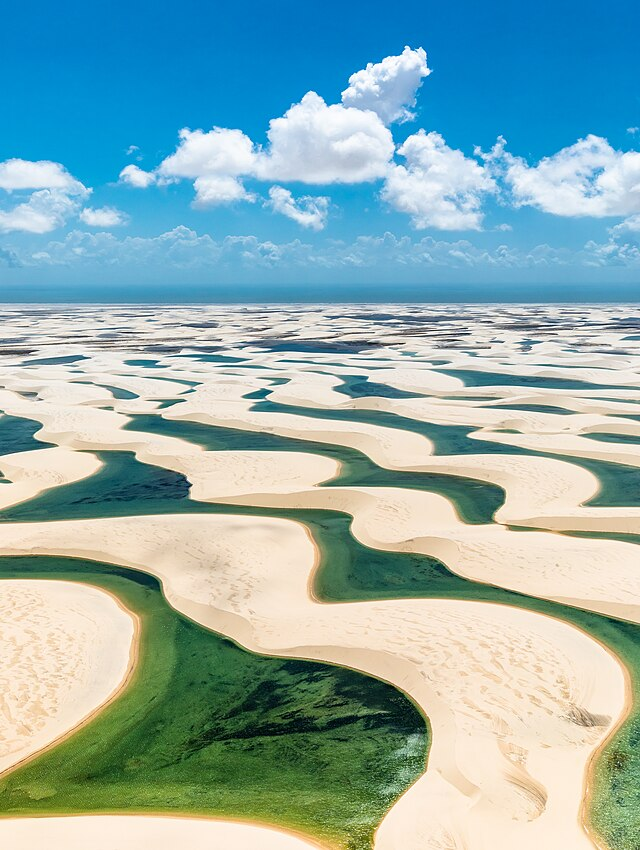What do you think is going on in this snapshot? The snapshot presents a stunning aerial view of Brazil's Lençóis Maranhenses National Park. The visual is striking, with waves of stark white sand dunes stretching across the landscape, reminiscent of an otherworldly desert. But, unlike a typical desert, the meandering patterns are occasionally punctuated by tranquil lagoons, their waters ranging from azure to emerald, a seasonal phenomenon caused by the region's rainfall. The contrast is visually arresting and speaks to the unique ecosystem here, where life flourishes despite the barren appearance. In this natural masterpiece, the rare geographical features are brought to life under the radiant sun that casts dynamic shadows, adding depth and drama to the scene. The park's rare beauty draws adventurers and photographers alike, all eager to capture its sublime duality of desert and water. 